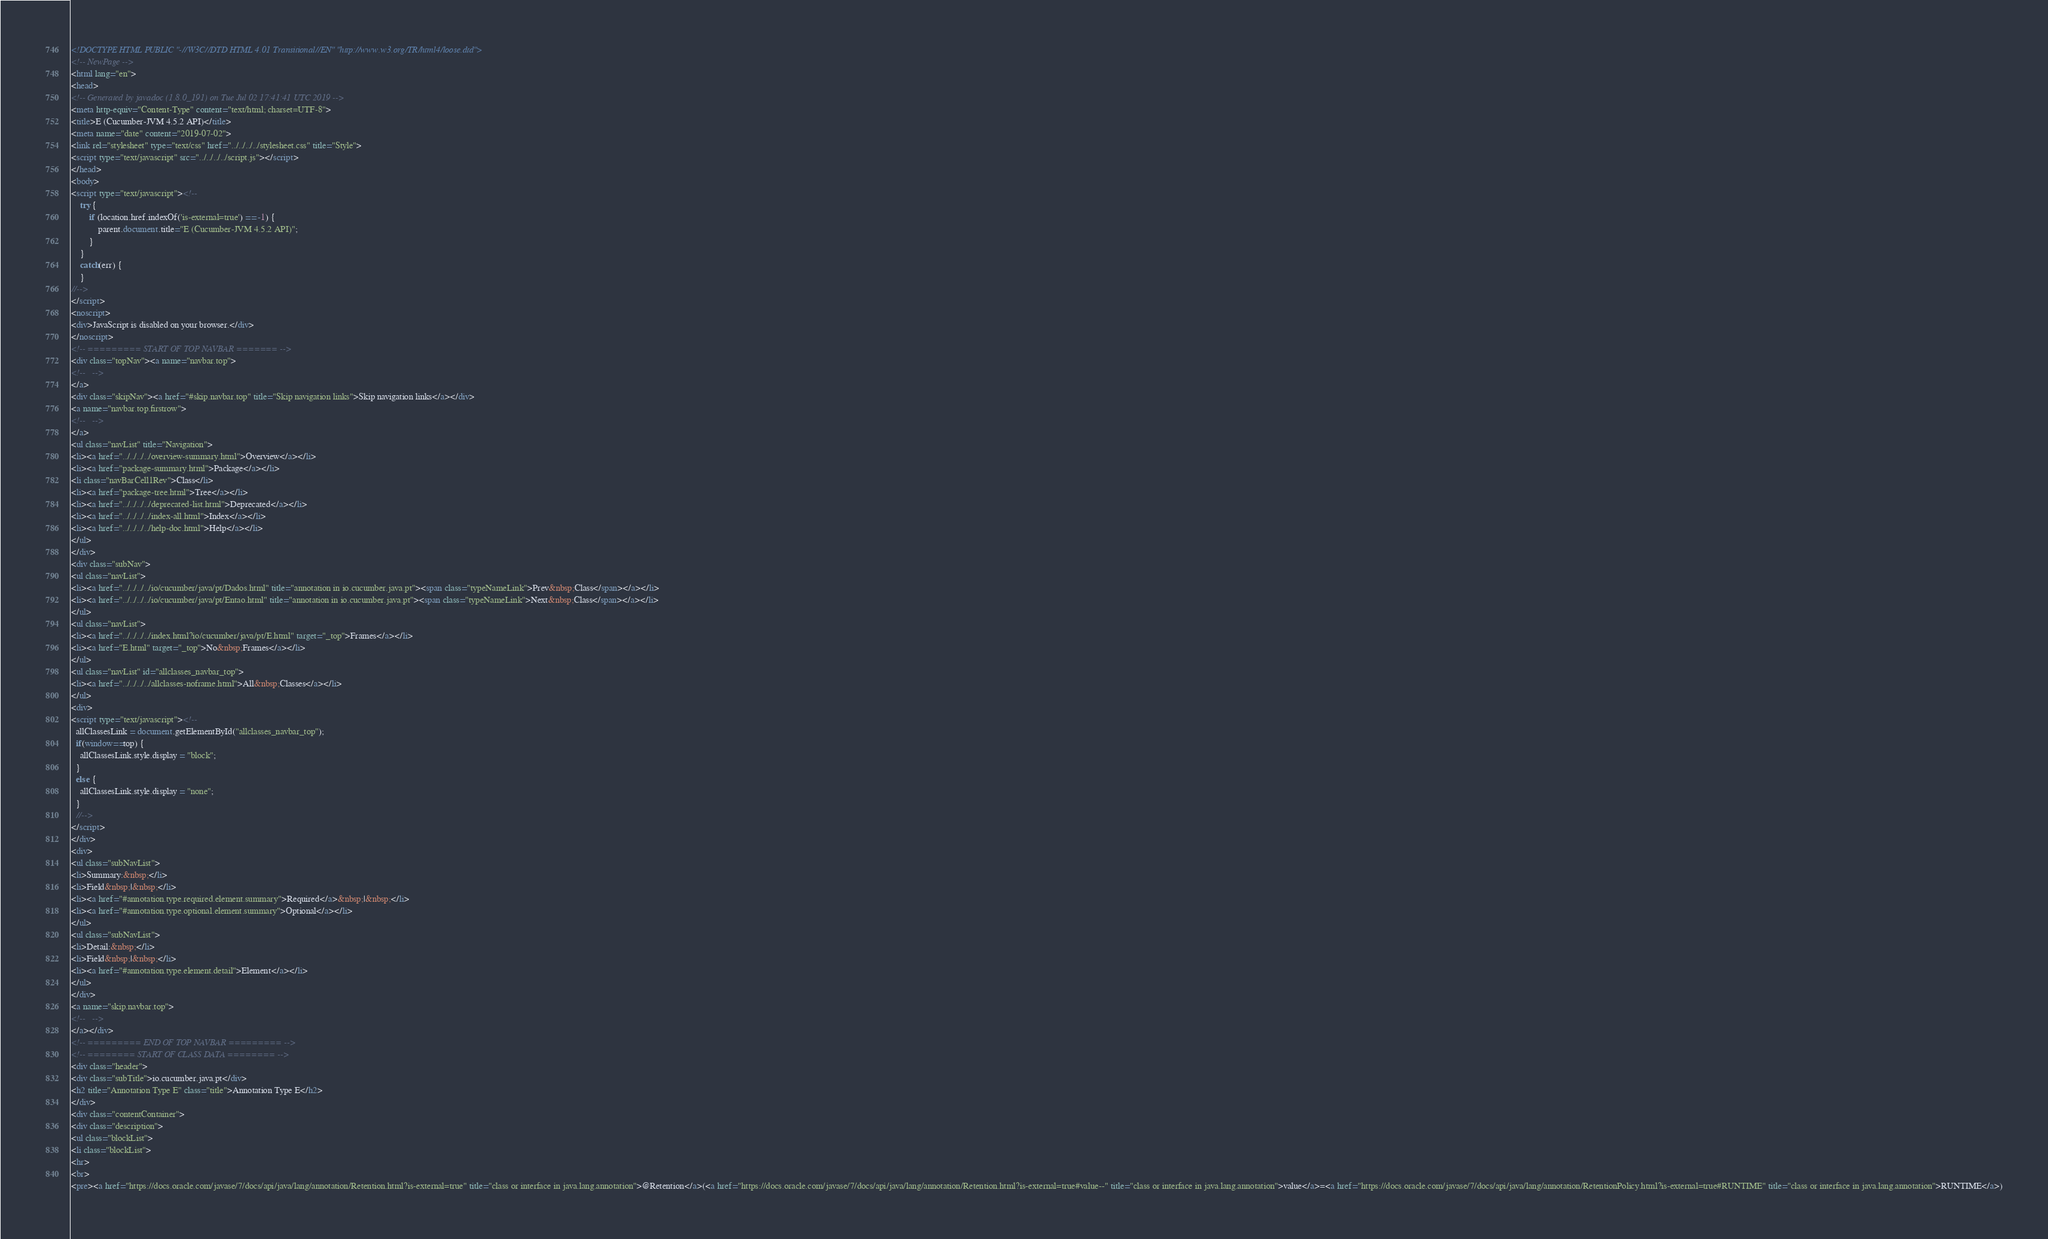Convert code to text. <code><loc_0><loc_0><loc_500><loc_500><_HTML_><!DOCTYPE HTML PUBLIC "-//W3C//DTD HTML 4.01 Transitional//EN" "http://www.w3.org/TR/html4/loose.dtd">
<!-- NewPage -->
<html lang="en">
<head>
<!-- Generated by javadoc (1.8.0_191) on Tue Jul 02 17:41:41 UTC 2019 -->
<meta http-equiv="Content-Type" content="text/html; charset=UTF-8">
<title>E (Cucumber-JVM 4.5.2 API)</title>
<meta name="date" content="2019-07-02">
<link rel="stylesheet" type="text/css" href="../../../../stylesheet.css" title="Style">
<script type="text/javascript" src="../../../../script.js"></script>
</head>
<body>
<script type="text/javascript"><!--
    try {
        if (location.href.indexOf('is-external=true') == -1) {
            parent.document.title="E (Cucumber-JVM 4.5.2 API)";
        }
    }
    catch(err) {
    }
//-->
</script>
<noscript>
<div>JavaScript is disabled on your browser.</div>
</noscript>
<!-- ========= START OF TOP NAVBAR ======= -->
<div class="topNav"><a name="navbar.top">
<!--   -->
</a>
<div class="skipNav"><a href="#skip.navbar.top" title="Skip navigation links">Skip navigation links</a></div>
<a name="navbar.top.firstrow">
<!--   -->
</a>
<ul class="navList" title="Navigation">
<li><a href="../../../../overview-summary.html">Overview</a></li>
<li><a href="package-summary.html">Package</a></li>
<li class="navBarCell1Rev">Class</li>
<li><a href="package-tree.html">Tree</a></li>
<li><a href="../../../../deprecated-list.html">Deprecated</a></li>
<li><a href="../../../../index-all.html">Index</a></li>
<li><a href="../../../../help-doc.html">Help</a></li>
</ul>
</div>
<div class="subNav">
<ul class="navList">
<li><a href="../../../../io/cucumber/java/pt/Dados.html" title="annotation in io.cucumber.java.pt"><span class="typeNameLink">Prev&nbsp;Class</span></a></li>
<li><a href="../../../../io/cucumber/java/pt/Entao.html" title="annotation in io.cucumber.java.pt"><span class="typeNameLink">Next&nbsp;Class</span></a></li>
</ul>
<ul class="navList">
<li><a href="../../../../index.html?io/cucumber/java/pt/E.html" target="_top">Frames</a></li>
<li><a href="E.html" target="_top">No&nbsp;Frames</a></li>
</ul>
<ul class="navList" id="allclasses_navbar_top">
<li><a href="../../../../allclasses-noframe.html">All&nbsp;Classes</a></li>
</ul>
<div>
<script type="text/javascript"><!--
  allClassesLink = document.getElementById("allclasses_navbar_top");
  if(window==top) {
    allClassesLink.style.display = "block";
  }
  else {
    allClassesLink.style.display = "none";
  }
  //-->
</script>
</div>
<div>
<ul class="subNavList">
<li>Summary:&nbsp;</li>
<li>Field&nbsp;|&nbsp;</li>
<li><a href="#annotation.type.required.element.summary">Required</a>&nbsp;|&nbsp;</li>
<li><a href="#annotation.type.optional.element.summary">Optional</a></li>
</ul>
<ul class="subNavList">
<li>Detail:&nbsp;</li>
<li>Field&nbsp;|&nbsp;</li>
<li><a href="#annotation.type.element.detail">Element</a></li>
</ul>
</div>
<a name="skip.navbar.top">
<!--   -->
</a></div>
<!-- ========= END OF TOP NAVBAR ========= -->
<!-- ======== START OF CLASS DATA ======== -->
<div class="header">
<div class="subTitle">io.cucumber.java.pt</div>
<h2 title="Annotation Type E" class="title">Annotation Type E</h2>
</div>
<div class="contentContainer">
<div class="description">
<ul class="blockList">
<li class="blockList">
<hr>
<br>
<pre><a href="https://docs.oracle.com/javase/7/docs/api/java/lang/annotation/Retention.html?is-external=true" title="class or interface in java.lang.annotation">@Retention</a>(<a href="https://docs.oracle.com/javase/7/docs/api/java/lang/annotation/Retention.html?is-external=true#value--" title="class or interface in java.lang.annotation">value</a>=<a href="https://docs.oracle.com/javase/7/docs/api/java/lang/annotation/RetentionPolicy.html?is-external=true#RUNTIME" title="class or interface in java.lang.annotation">RUNTIME</a>)</code> 